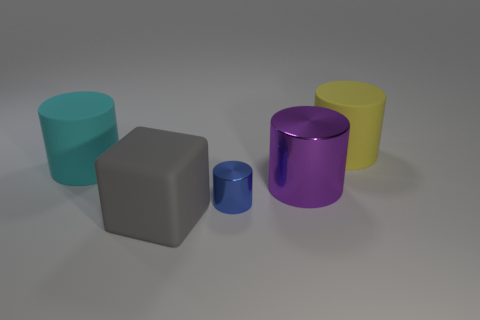What number of other objects are there of the same size as the purple metallic thing?
Make the answer very short. 3. Does the cyan cylinder have the same material as the thing behind the cyan thing?
Offer a very short reply. Yes. What is the shape of the big rubber object in front of the large cylinder to the left of the big purple metal cylinder?
Ensure brevity in your answer.  Cube. There is a matte thing that is both on the left side of the big yellow rubber thing and behind the rubber cube; what is its shape?
Keep it short and to the point. Cylinder. What number of objects are gray matte things or large things to the right of the blue metallic cylinder?
Give a very brief answer. 3. There is a big purple thing that is the same shape as the blue metal object; what material is it?
Your answer should be compact. Metal. Is there any other thing that is the same material as the big block?
Give a very brief answer. Yes. There is a big cylinder that is both in front of the big yellow rubber cylinder and to the right of the rubber cube; what is its material?
Keep it short and to the point. Metal. What number of big cyan objects are the same shape as the big purple object?
Offer a very short reply. 1. The large thing that is behind the cyan matte cylinder behind the blue cylinder is what color?
Provide a succinct answer. Yellow. 